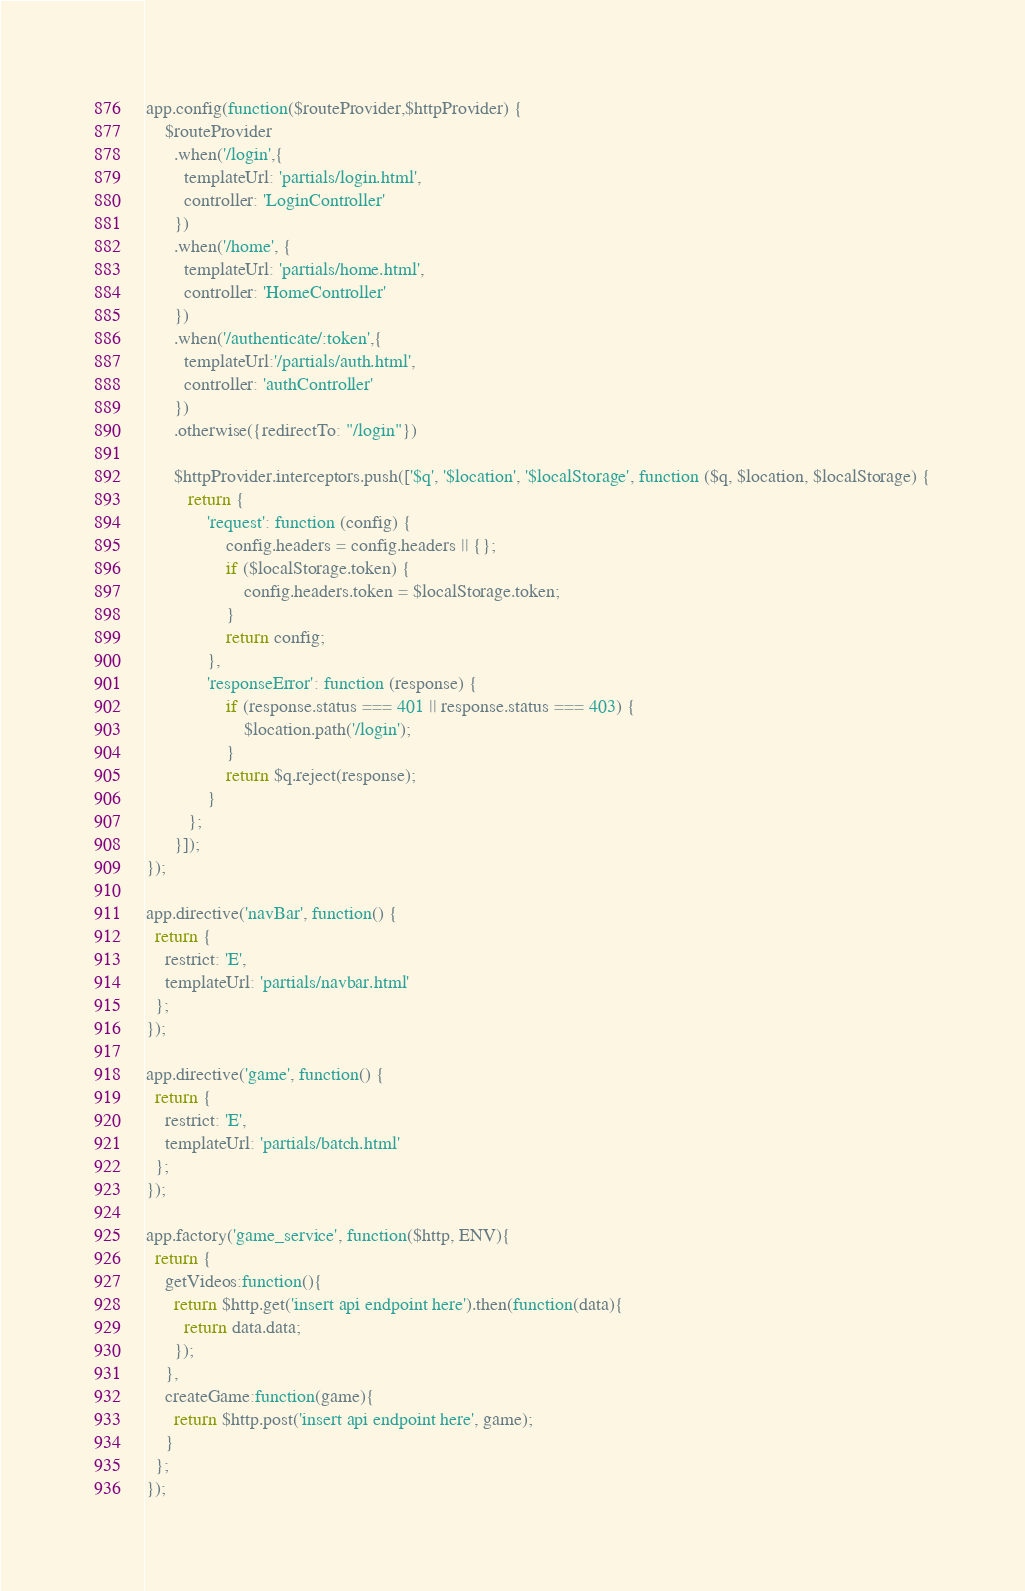<code> <loc_0><loc_0><loc_500><loc_500><_JavaScript_>app.config(function($routeProvider,$httpProvider) {
    $routeProvider
      .when('/login',{
        templateUrl: 'partials/login.html',
        controller: 'LoginController'
      })
      .when('/home', {
        templateUrl: 'partials/home.html',
        controller: 'HomeController'
      })
      .when('/authenticate/:token',{
        templateUrl:'/partials/auth.html',
        controller: 'authController'
      })
      .otherwise({redirectTo: "/login"})

      $httpProvider.interceptors.push(['$q', '$location', '$localStorage', function ($q, $location, $localStorage) {
         return {
             'request': function (config) {
                 config.headers = config.headers || {};
                 if ($localStorage.token) {
                     config.headers.token = $localStorage.token;
                 }
                 return config;
             },
             'responseError': function (response) {
                 if (response.status === 401 || response.status === 403) {
                     $location.path('/login');
                 }
                 return $q.reject(response);
             }
         };
      }]);
});

app.directive('navBar', function() {
  return {
    restrict: 'E',
    templateUrl: 'partials/navbar.html'
  };
});

app.directive('game', function() {
  return {
    restrict: 'E',
    templateUrl: 'partials/batch.html'
  };
});

app.factory('game_service', function($http, ENV){
  return {
    getVideos:function(){
      return $http.get('insert api endpoint here').then(function(data){
        return data.data;
      });
    },
    createGame:function(game){
      return $http.post('insert api endpoint here', game);
    }
  };
});
</code> 